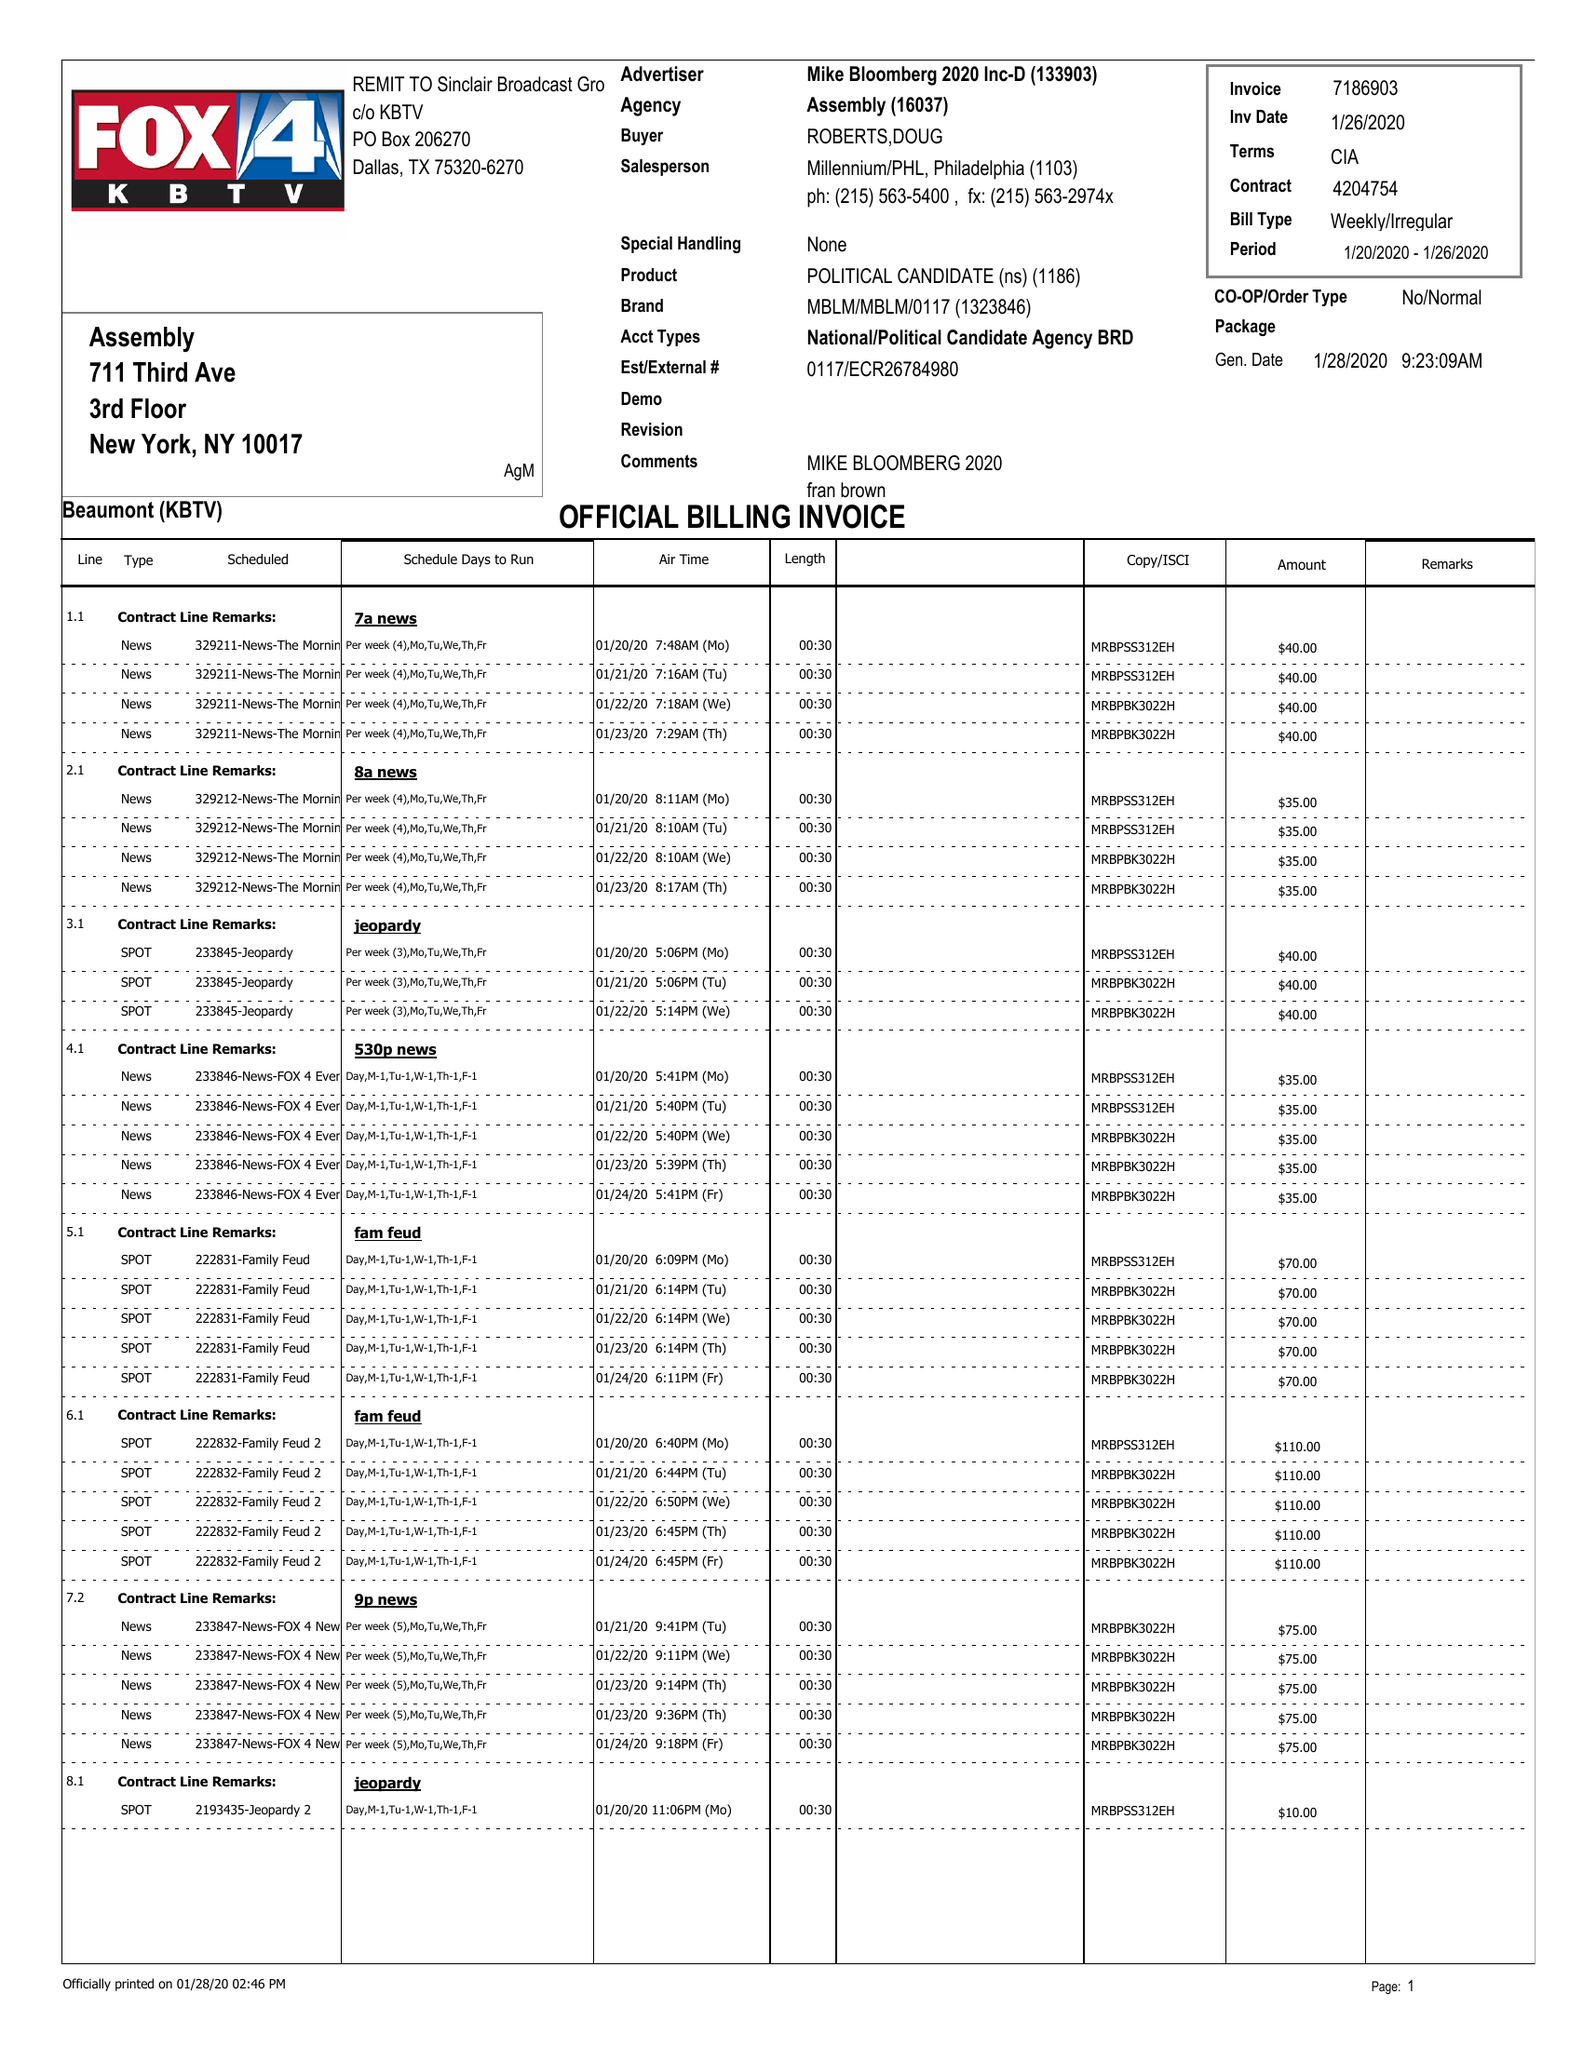What is the value for the contract_num?
Answer the question using a single word or phrase. 4204754 